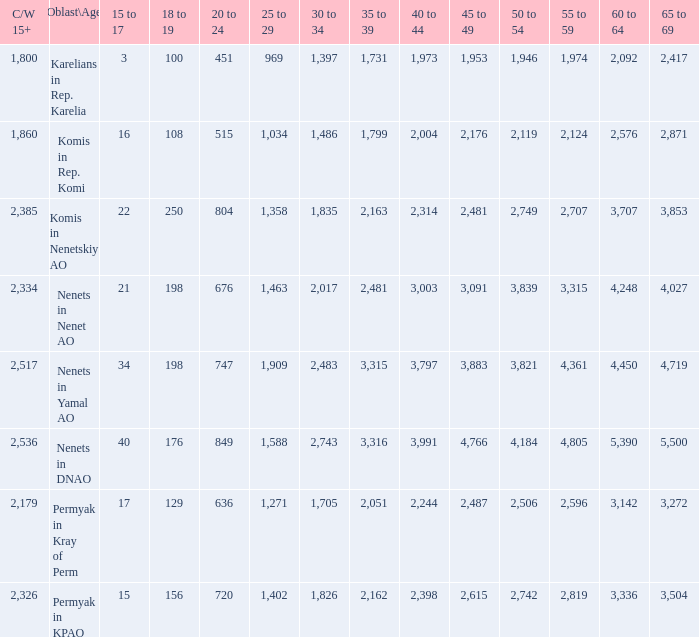What is the total 30 to 34 when the 40 to 44 is greater than 3,003, and the 50 to 54 is greater than 4,184? None. 